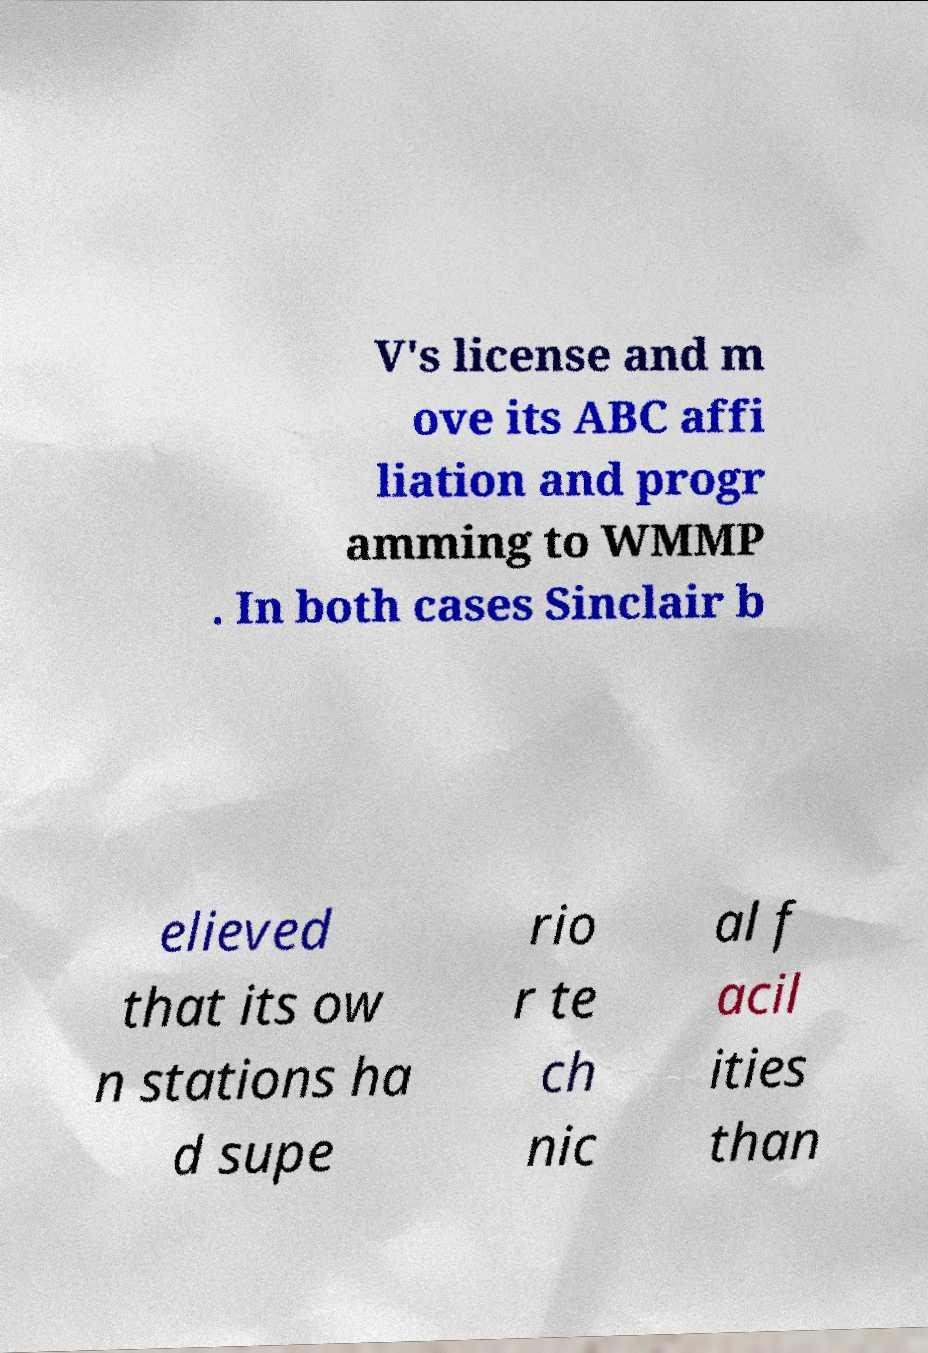Please read and relay the text visible in this image. What does it say? V's license and m ove its ABC affi liation and progr amming to WMMP . In both cases Sinclair b elieved that its ow n stations ha d supe rio r te ch nic al f acil ities than 